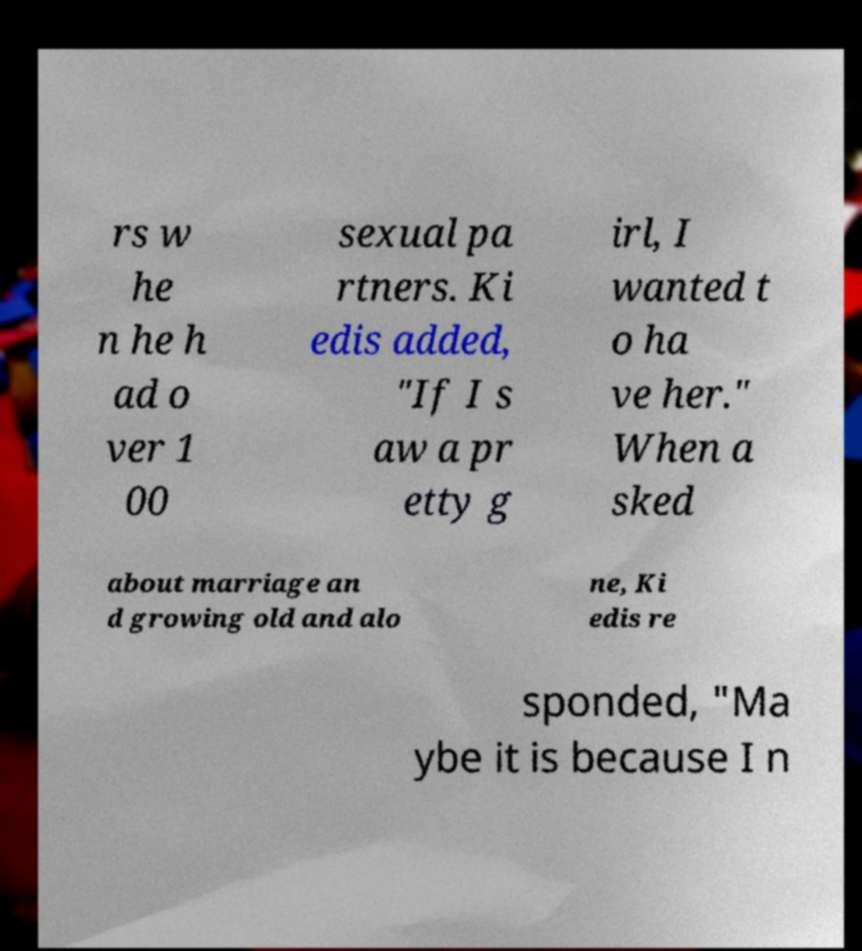Could you assist in decoding the text presented in this image and type it out clearly? rs w he n he h ad o ver 1 00 sexual pa rtners. Ki edis added, "If I s aw a pr etty g irl, I wanted t o ha ve her." When a sked about marriage an d growing old and alo ne, Ki edis re sponded, "Ma ybe it is because I n 